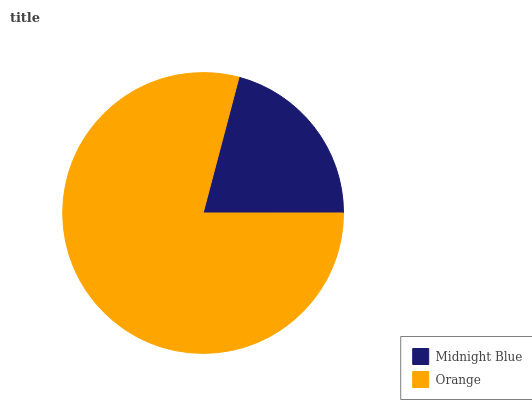Is Midnight Blue the minimum?
Answer yes or no. Yes. Is Orange the maximum?
Answer yes or no. Yes. Is Orange the minimum?
Answer yes or no. No. Is Orange greater than Midnight Blue?
Answer yes or no. Yes. Is Midnight Blue less than Orange?
Answer yes or no. Yes. Is Midnight Blue greater than Orange?
Answer yes or no. No. Is Orange less than Midnight Blue?
Answer yes or no. No. Is Orange the high median?
Answer yes or no. Yes. Is Midnight Blue the low median?
Answer yes or no. Yes. Is Midnight Blue the high median?
Answer yes or no. No. Is Orange the low median?
Answer yes or no. No. 